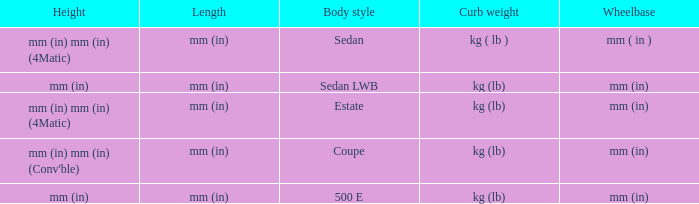What's the length of the model with 500 E body style? Mm (in). 